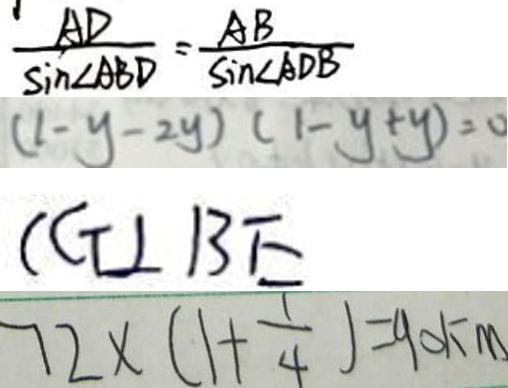Convert formula to latex. <formula><loc_0><loc_0><loc_500><loc_500>\frac { A D } { \sin \angle A B D } = \frac { A B } { \sin \angle A D B } 
 ( 1 - y - 2 y ) ( 1 - y + y ) = 0 
 ( G \bot B E 
 7 2 \times ( 1 + \frac { 1 } { 4 } ) = 9 0 k m</formula> 